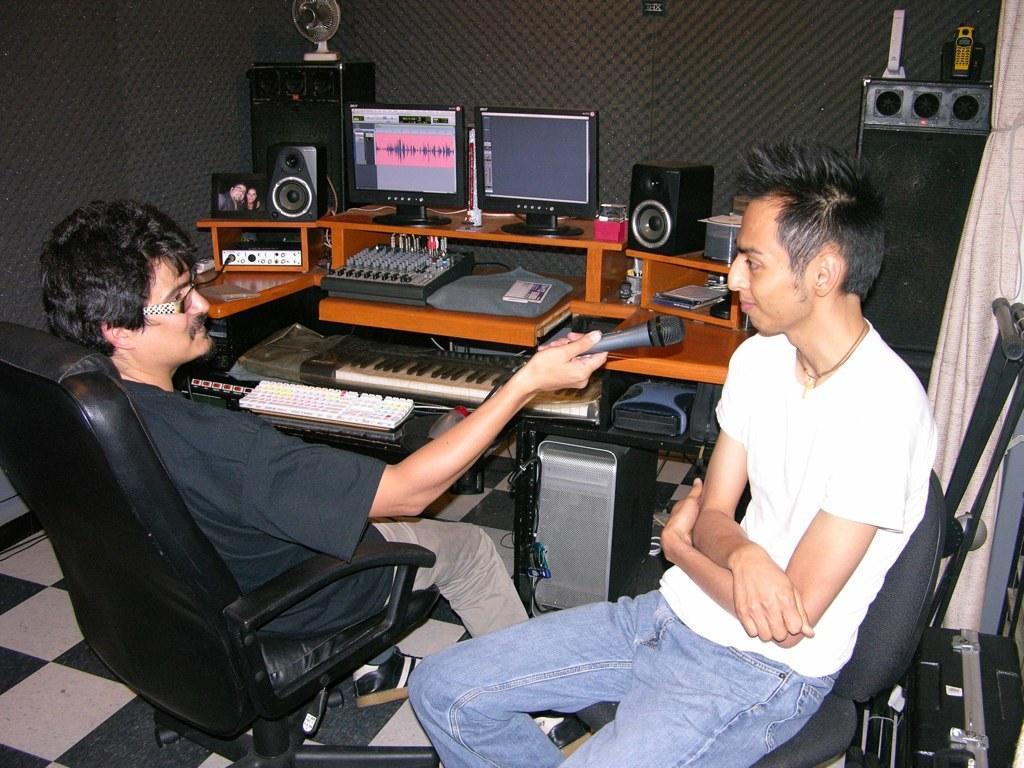Please provide a concise description of this image. There are two people sitting on the chairs. Here is a man holding mike. These are the two monitors,speakers,photo frame,piano,keyboard and this looks like a electronic device and some objects placed on the table. This looks like another speaker. I can see a cell phone placed on the speaker. This is the curtain hanging. 